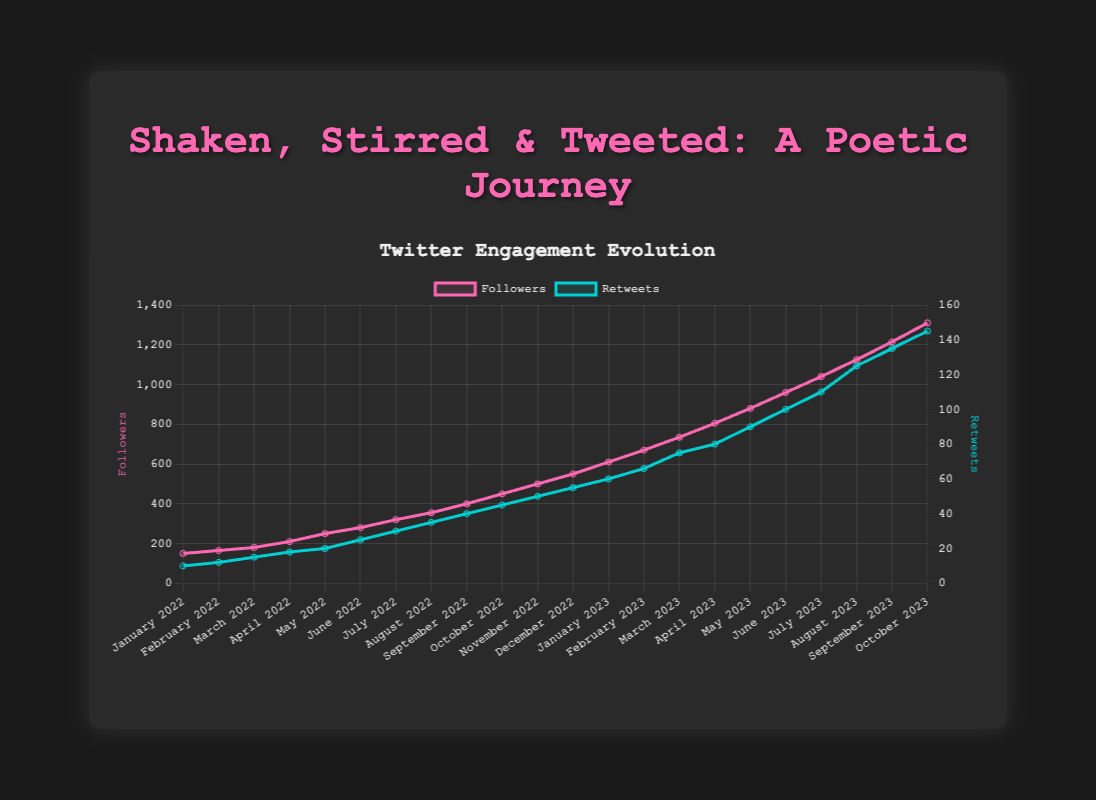How many followers did the poetry mixologist gain from January 2022 to December 2022? To find the number of followers gained, subtract the follower count in January 2022 from December 2022: 550 - 150.
Answer: 400 Which month in 2023 saw the highest increase in followers compared to the previous month? Compare the follower count of each month with the previous month in 2023. The highest increase is between September 2023 and August 2023 (1215 - 1125 = 90 followers).
Answer: September 2023 How many total retweets did the poetry mixologist receive in the first half of 2022? Add the retweets from January 2022 to June 2022: 10 + 12 + 15 + 18 + 20 + 25.
Answer: 100 Which month had the same increase in both follower count and retweets from the previous month, and what was the value of the increase? By examining the dataset, March 2023 shows an increase of 65 followers (735 - 670) and 9 retweets (75 - 66).
Answer: March 2023, increase of 65 followers and 9 retweets During which month in 2022 did the number of retweets surpass 30 for the first time? Check each month's retweets in 2022 until finding the first month surpassing 30 retweets, which is July 2022.
Answer: July 2022 Comparing the engagement, which had a steeper rise: followers or retweets, by October 2023? Examine the slopes of both datasets. The number of followers rose from 150 to 1310, and retweets from 10 to 145 over the same period. Calculate the respective slopes and compare: Followers increased by 1160 (1310 - 150), and retweets by 135 (145 - 10).
Answer: Followers How many months did it take for the poetry mixologist to double their follower count from January 2022? January 2022 had 150 followers. Doubling that is 300. This count is surpassed in July 2022.
Answer: 6 months Which month saw the smallest relative increase in followers from the previous month in 2023? Calculate the relative increase for each month of 2023: (January from December 2022, February from January 2023, ...). March 2023 had the smallest relative increase of approximately 10.2%.
Answer: March 2023 